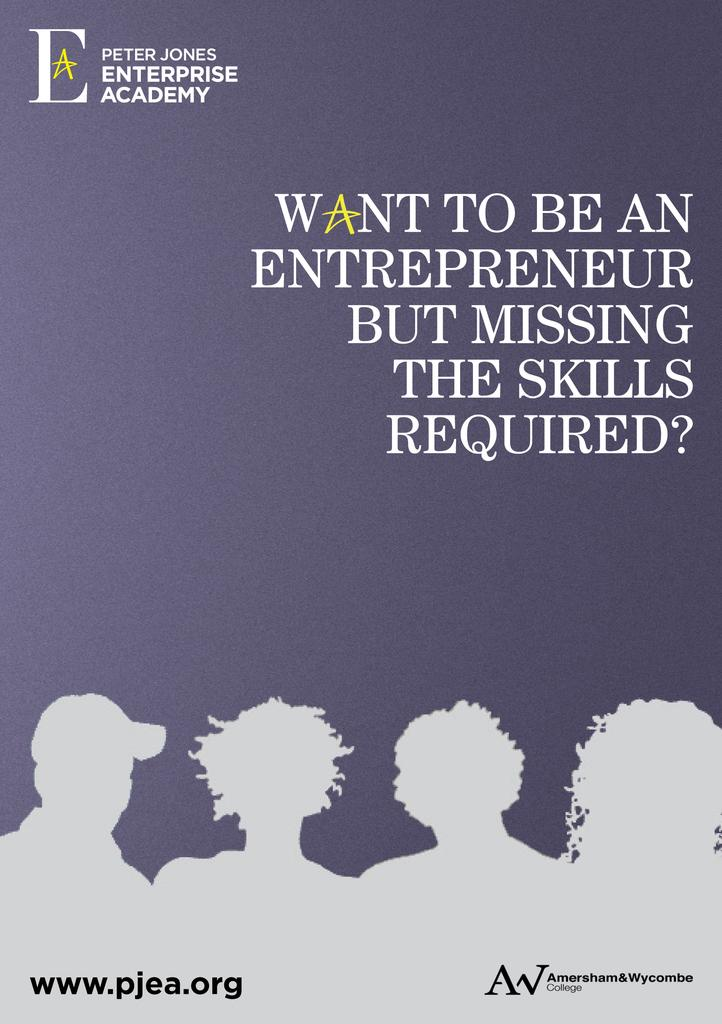<image>
Relay a brief, clear account of the picture shown. Amersham & Wycombe college poster advertising their enterprise academy for entrepreneurs. 